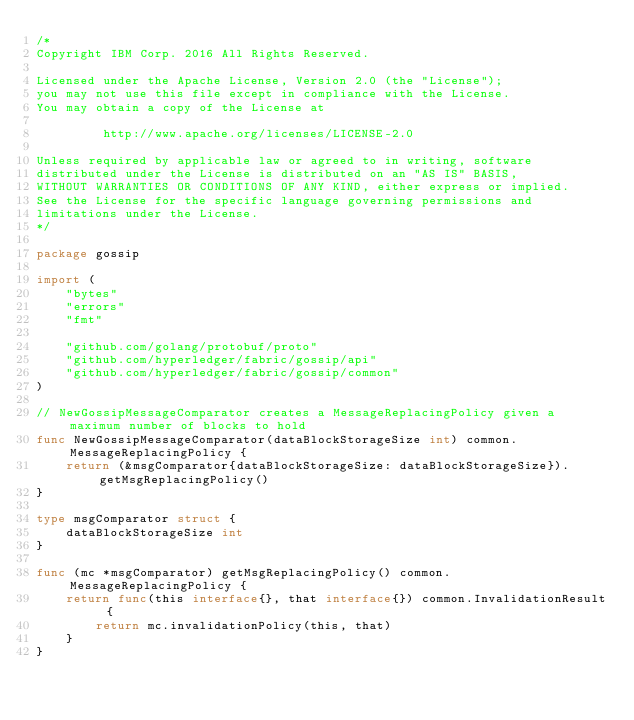Convert code to text. <code><loc_0><loc_0><loc_500><loc_500><_Go_>/*
Copyright IBM Corp. 2016 All Rights Reserved.

Licensed under the Apache License, Version 2.0 (the "License");
you may not use this file except in compliance with the License.
You may obtain a copy of the License at

		 http://www.apache.org/licenses/LICENSE-2.0

Unless required by applicable law or agreed to in writing, software
distributed under the License is distributed on an "AS IS" BASIS,
WITHOUT WARRANTIES OR CONDITIONS OF ANY KIND, either express or implied.
See the License for the specific language governing permissions and
limitations under the License.
*/

package gossip

import (
	"bytes"
	"errors"
	"fmt"

	"github.com/golang/protobuf/proto"
	"github.com/hyperledger/fabric/gossip/api"
	"github.com/hyperledger/fabric/gossip/common"
)

// NewGossipMessageComparator creates a MessageReplacingPolicy given a maximum number of blocks to hold
func NewGossipMessageComparator(dataBlockStorageSize int) common.MessageReplacingPolicy {
	return (&msgComparator{dataBlockStorageSize: dataBlockStorageSize}).getMsgReplacingPolicy()
}

type msgComparator struct {
	dataBlockStorageSize int
}

func (mc *msgComparator) getMsgReplacingPolicy() common.MessageReplacingPolicy {
	return func(this interface{}, that interface{}) common.InvalidationResult {
		return mc.invalidationPolicy(this, that)
	}
}
</code> 